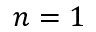<formula> <loc_0><loc_0><loc_500><loc_500>n = 1</formula> 